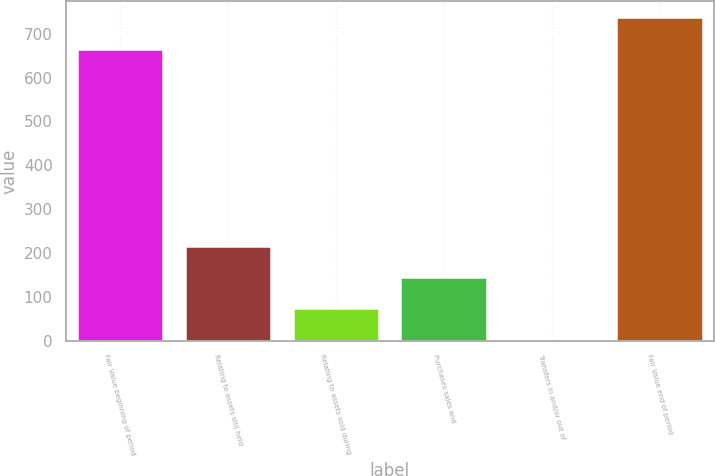Convert chart. <chart><loc_0><loc_0><loc_500><loc_500><bar_chart><fcel>Fair Value beginning of period<fcel>Relating to assets still held<fcel>Relating to assets sold during<fcel>Purchases sales and<fcel>Transfers in and/or out of<fcel>Fair Value end of period<nl><fcel>666<fcel>215.98<fcel>73.7<fcel>144.84<fcel>2.56<fcel>737.14<nl></chart> 